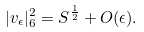<formula> <loc_0><loc_0><loc_500><loc_500>| v _ { \epsilon } | ^ { 2 } _ { 6 } = S ^ { \frac { 1 } { 2 } } + O ( \epsilon ) .</formula> 